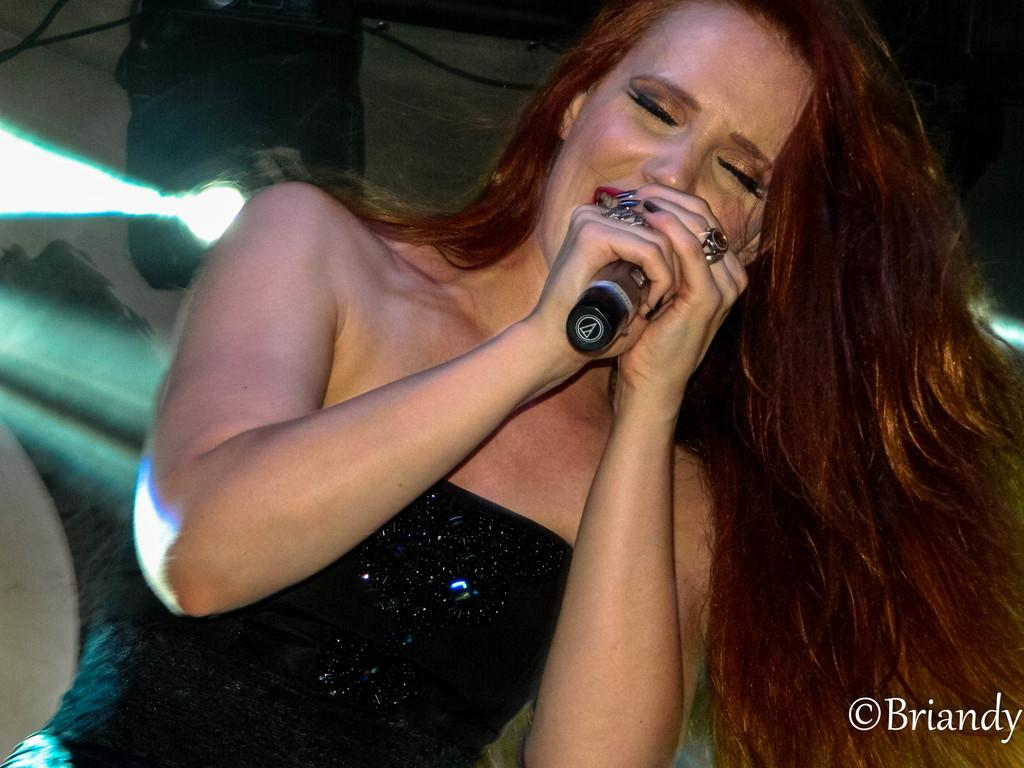Who is the main subject in the image? There is a woman in the image. What is the woman holding in her hands? The woman is holding a microphone in her hands. Is there any text or logo visible in the image? Yes, there is a watermark in the bottom right corner of the image. What can be seen in the background of the image? There are lights visible in the background of the image. What type of pear is the woman eating in the image? There is no pear present in the image; the woman is holding a microphone. Can you tell me how many sheep are visible in the image? There are no sheep present in the image. 